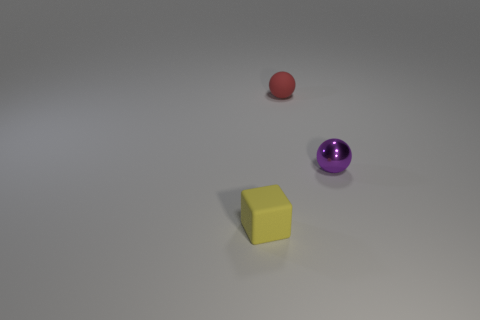What is the color of the tiny sphere that is left of the ball that is to the right of the sphere left of the small purple metal thing?
Your response must be concise. Red. There is a object that is in front of the purple sphere; does it have the same color as the shiny object?
Ensure brevity in your answer.  No. What number of other things are the same color as the tiny shiny thing?
Your response must be concise. 0. What number of objects are either purple things or big gray cylinders?
Your answer should be compact. 1. How many things are either small red things or small balls behind the small purple shiny ball?
Provide a succinct answer. 1. Do the purple ball and the small red object have the same material?
Your response must be concise. No. What number of other things are there of the same material as the yellow cube
Your response must be concise. 1. Is the number of blue rubber cylinders greater than the number of tiny red matte objects?
Provide a succinct answer. No. There is a tiny thing that is behind the tiny metal ball; does it have the same shape as the small purple shiny thing?
Provide a short and direct response. Yes. Are there fewer blue rubber cylinders than small red rubber objects?
Offer a very short reply. Yes. 